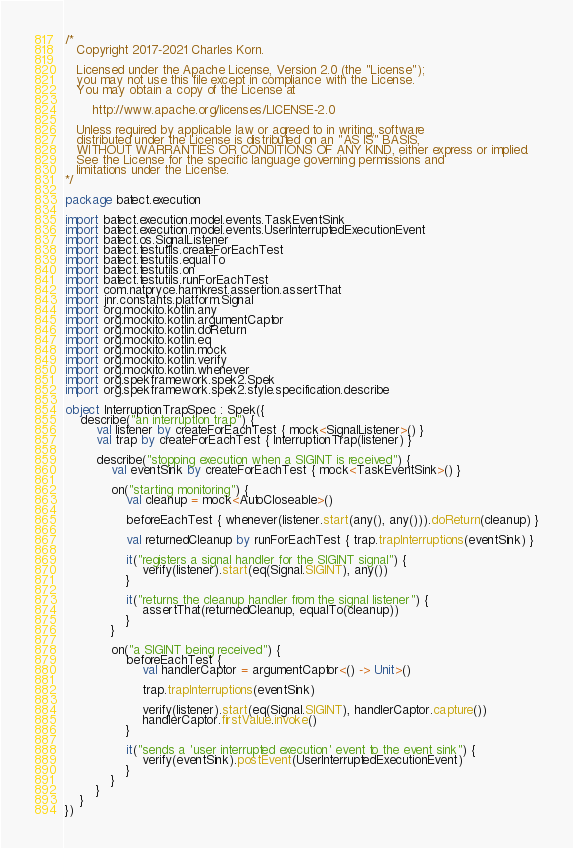<code> <loc_0><loc_0><loc_500><loc_500><_Kotlin_>/*
   Copyright 2017-2021 Charles Korn.

   Licensed under the Apache License, Version 2.0 (the "License");
   you may not use this file except in compliance with the License.
   You may obtain a copy of the License at

       http://www.apache.org/licenses/LICENSE-2.0

   Unless required by applicable law or agreed to in writing, software
   distributed under the License is distributed on an "AS IS" BASIS,
   WITHOUT WARRANTIES OR CONDITIONS OF ANY KIND, either express or implied.
   See the License for the specific language governing permissions and
   limitations under the License.
*/

package batect.execution

import batect.execution.model.events.TaskEventSink
import batect.execution.model.events.UserInterruptedExecutionEvent
import batect.os.SignalListener
import batect.testutils.createForEachTest
import batect.testutils.equalTo
import batect.testutils.on
import batect.testutils.runForEachTest
import com.natpryce.hamkrest.assertion.assertThat
import jnr.constants.platform.Signal
import org.mockito.kotlin.any
import org.mockito.kotlin.argumentCaptor
import org.mockito.kotlin.doReturn
import org.mockito.kotlin.eq
import org.mockito.kotlin.mock
import org.mockito.kotlin.verify
import org.mockito.kotlin.whenever
import org.spekframework.spek2.Spek
import org.spekframework.spek2.style.specification.describe

object InterruptionTrapSpec : Spek({
    describe("an interruption trap") {
        val listener by createForEachTest { mock<SignalListener>() }
        val trap by createForEachTest { InterruptionTrap(listener) }

        describe("stopping execution when a SIGINT is received") {
            val eventSink by createForEachTest { mock<TaskEventSink>() }

            on("starting monitoring") {
                val cleanup = mock<AutoCloseable>()

                beforeEachTest { whenever(listener.start(any(), any())).doReturn(cleanup) }

                val returnedCleanup by runForEachTest { trap.trapInterruptions(eventSink) }

                it("registers a signal handler for the SIGINT signal") {
                    verify(listener).start(eq(Signal.SIGINT), any())
                }

                it("returns the cleanup handler from the signal listener") {
                    assertThat(returnedCleanup, equalTo(cleanup))
                }
            }

            on("a SIGINT being received") {
                beforeEachTest {
                    val handlerCaptor = argumentCaptor<() -> Unit>()

                    trap.trapInterruptions(eventSink)

                    verify(listener).start(eq(Signal.SIGINT), handlerCaptor.capture())
                    handlerCaptor.firstValue.invoke()
                }

                it("sends a 'user interrupted execution' event to the event sink") {
                    verify(eventSink).postEvent(UserInterruptedExecutionEvent)
                }
            }
        }
    }
})
</code> 